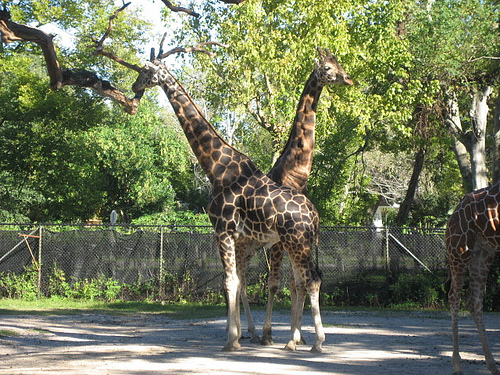<image>
Is there a giraffe on the tree shadow? Yes. Looking at the image, I can see the giraffe is positioned on top of the tree shadow, with the tree shadow providing support. 